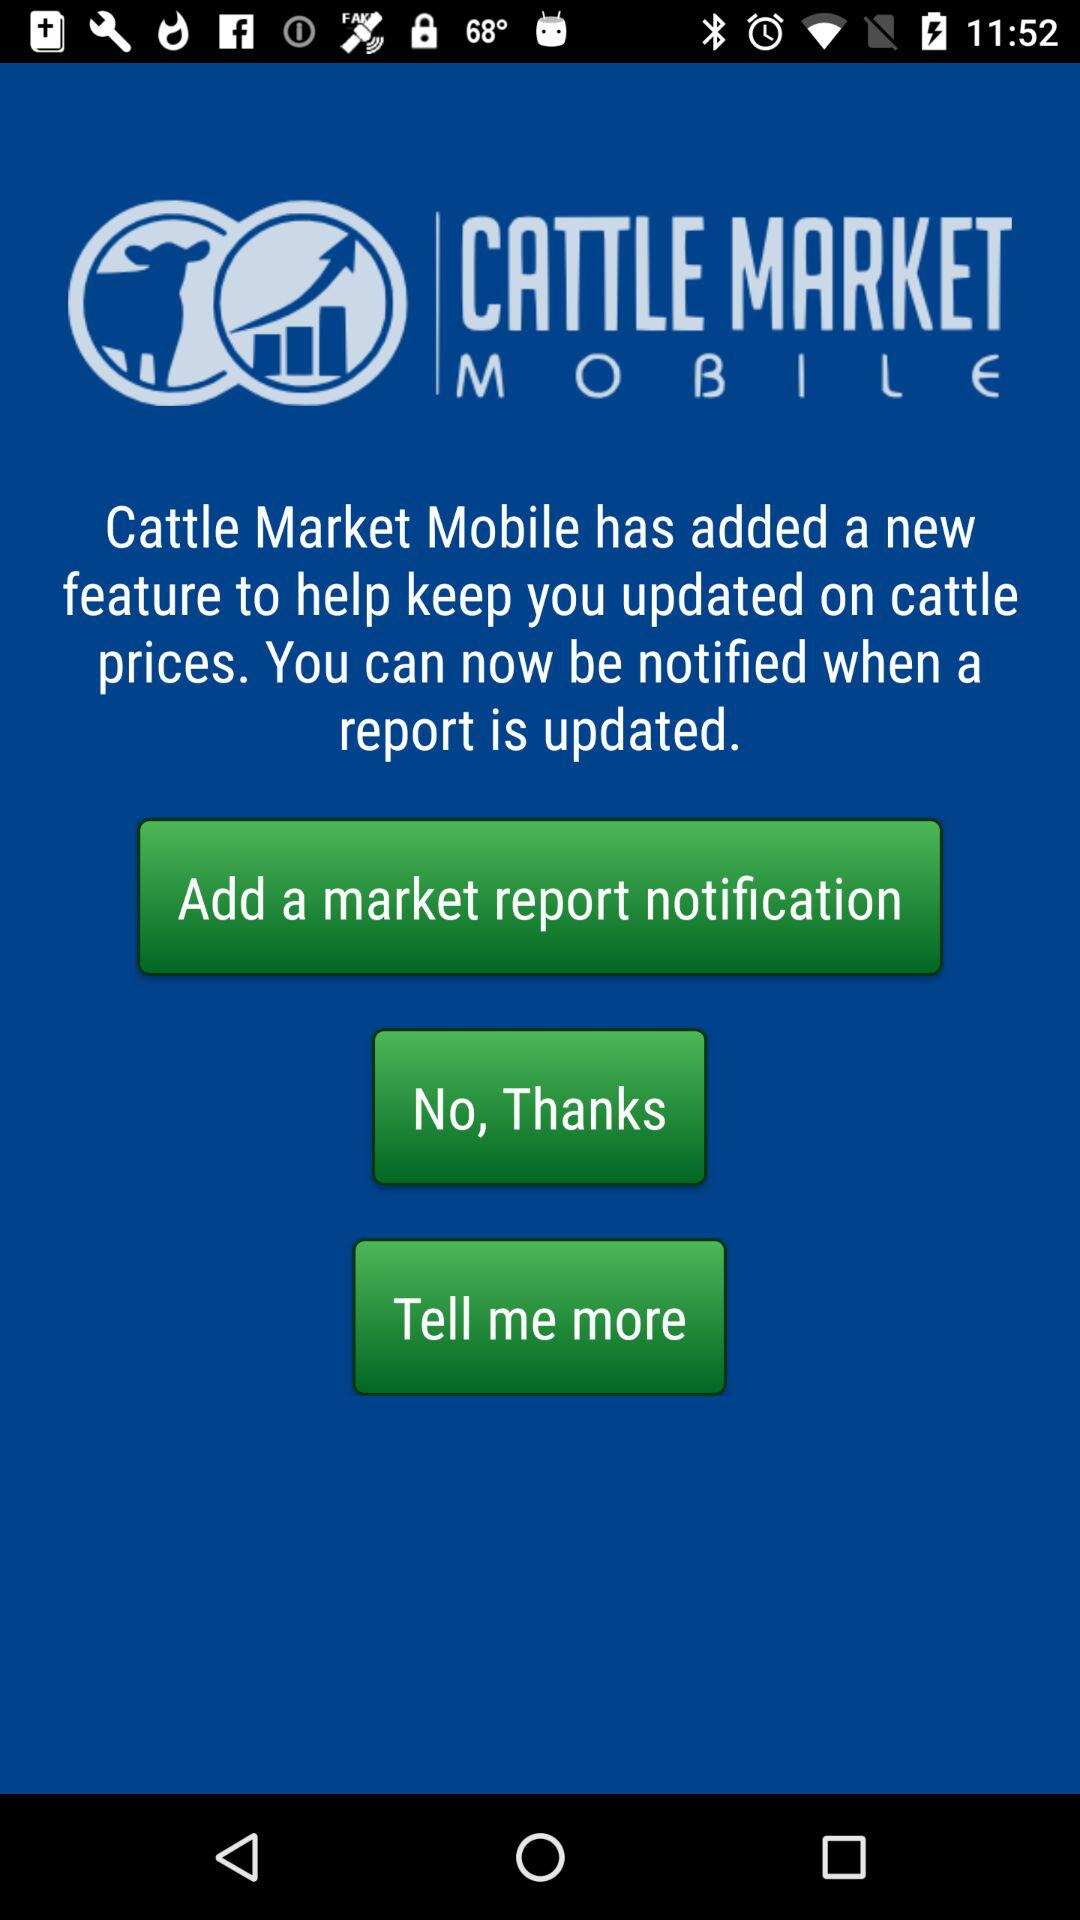What is the name of the application? The name of the application is "Cattle Market Mobile". 